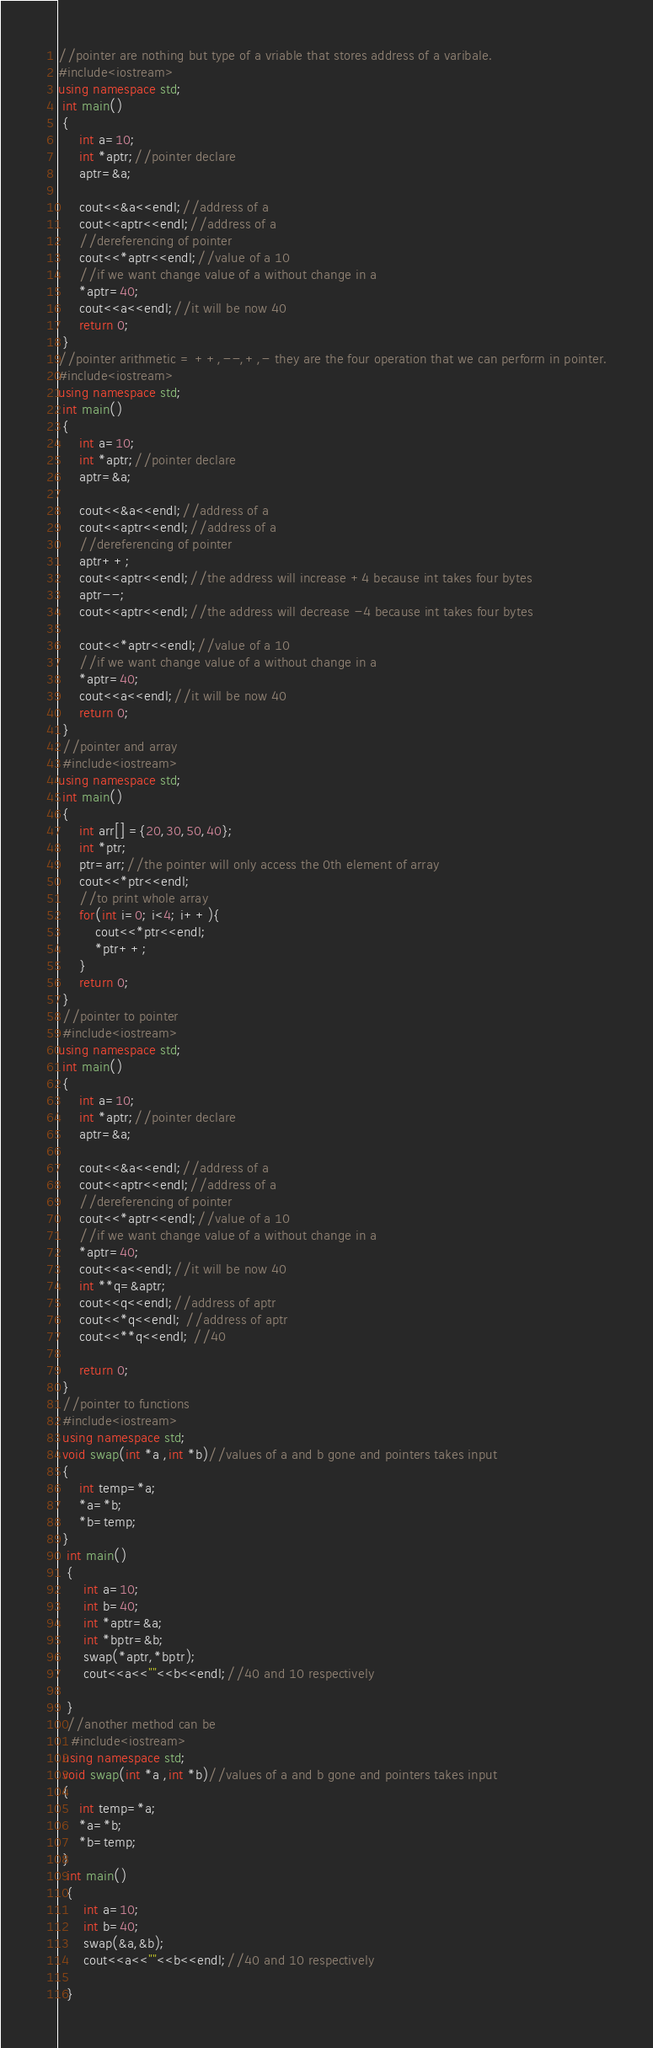<code> <loc_0><loc_0><loc_500><loc_500><_C++_>//pointer are nothing but type of a vriable that stores address of a varibale.
#include<iostream>
using namespace std;
 int main()
 {
     int a=10;
     int *aptr;//pointer declare
     aptr=&a;

     cout<<&a<<endl;//address of a
     cout<<aptr<<endl;//address of a
     //dereferencing of pointer
     cout<<*aptr<<endl;//value of a 10
     //if we want change value of a without change in a
     *aptr=40;
     cout<<a<<endl;//it will be now 40
     return 0;
 }
//pointer arithmetic = ++,--,+,- they are the four operation that we can perform in pointer.
#include<iostream>
using namespace std;
 int main()
 {
     int a=10;
     int *aptr;//pointer declare
     aptr=&a;

     cout<<&a<<endl;//address of a
     cout<<aptr<<endl;//address of a
     //dereferencing of pointer
     aptr++;
     cout<<aptr<<endl;//the address will increase +4 because int takes four bytes
     aptr--;
     cout<<aptr<<endl;//the address will decrease -4 because int takes four bytes
 
     cout<<*aptr<<endl;//value of a 10
     //if we want change value of a without change in a
     *aptr=40;
     cout<<a<<endl;//it will be now 40
     return 0;
 }
 //pointer and array
 #include<iostream>
using namespace std;
 int main()
 {
     int arr[] ={20,30,50,40};
     int *ptr;
     ptr=arr;//the pointer will only access the 0th element of array
     cout<<*ptr<<endl;
     //to print whole array
     for(int i=0; i<4; i++){
         cout<<*ptr<<endl;
         *ptr++;
     }
     return 0;
 }
 //pointer to pointer
 #include<iostream>
using namespace std;
 int main()
 {
     int a=10;
     int *aptr;//pointer declare
     aptr=&a;

     cout<<&a<<endl;//address of a
     cout<<aptr<<endl;//address of a
     //dereferencing of pointer
     cout<<*aptr<<endl;//value of a 10
     //if we want change value of a without change in a
     *aptr=40;
     cout<<a<<endl;//it will be now 40
     int **q=&aptr;
     cout<<q<<endl;//address of aptr
     cout<<*q<<endl; //address of aptr
     cout<<**q<<endl; //40

     return 0;
 }
 //pointer to functions
 #include<iostream>
 using namespace std;
 void swap(int *a ,int *b)//values of a and b gone and pointers takes input
 {
     int temp=*a;
     *a=*b;
     *b=temp;
 } 
  int main()
  {
      int a=10;
      int b=40;
      int *aptr=&a;
      int *bptr=&b;
      swap(*aptr,*bptr);
      cout<<a<<""<<b<<endl;//40 and 10 respectively

  }
  //another method can be
   #include<iostream>
 using namespace std;
 void swap(int *a ,int *b)//values of a and b gone and pointers takes input
 {
     int temp=*a;
     *a=*b;
     *b=temp;
 } 
  int main()
  {
      int a=10;
      int b=40;
      swap(&a,&b);
      cout<<a<<""<<b<<endl;//40 and 10 respectively

  }

</code> 